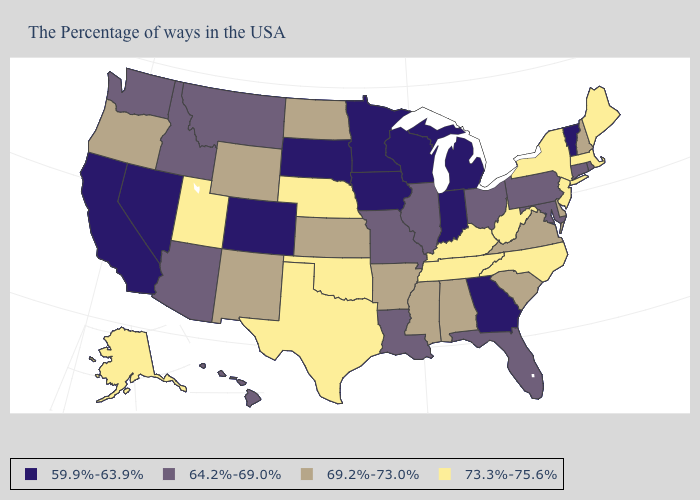Name the states that have a value in the range 59.9%-63.9%?
Keep it brief. Vermont, Georgia, Michigan, Indiana, Wisconsin, Minnesota, Iowa, South Dakota, Colorado, Nevada, California. Name the states that have a value in the range 64.2%-69.0%?
Quick response, please. Rhode Island, Connecticut, Maryland, Pennsylvania, Ohio, Florida, Illinois, Louisiana, Missouri, Montana, Arizona, Idaho, Washington, Hawaii. Name the states that have a value in the range 64.2%-69.0%?
Concise answer only. Rhode Island, Connecticut, Maryland, Pennsylvania, Ohio, Florida, Illinois, Louisiana, Missouri, Montana, Arizona, Idaho, Washington, Hawaii. Does the map have missing data?
Concise answer only. No. What is the highest value in the West ?
Quick response, please. 73.3%-75.6%. Does Vermont have the same value as Colorado?
Quick response, please. Yes. Does Oklahoma have the same value as Maryland?
Write a very short answer. No. Does Louisiana have the highest value in the South?
Give a very brief answer. No. Which states hav the highest value in the MidWest?
Answer briefly. Nebraska. What is the highest value in states that border New Mexico?
Answer briefly. 73.3%-75.6%. Name the states that have a value in the range 73.3%-75.6%?
Short answer required. Maine, Massachusetts, New York, New Jersey, North Carolina, West Virginia, Kentucky, Tennessee, Nebraska, Oklahoma, Texas, Utah, Alaska. What is the value of California?
Answer briefly. 59.9%-63.9%. What is the highest value in states that border Maryland?
Be succinct. 73.3%-75.6%. What is the value of Delaware?
Keep it brief. 69.2%-73.0%. Does Alaska have the same value as North Carolina?
Give a very brief answer. Yes. 